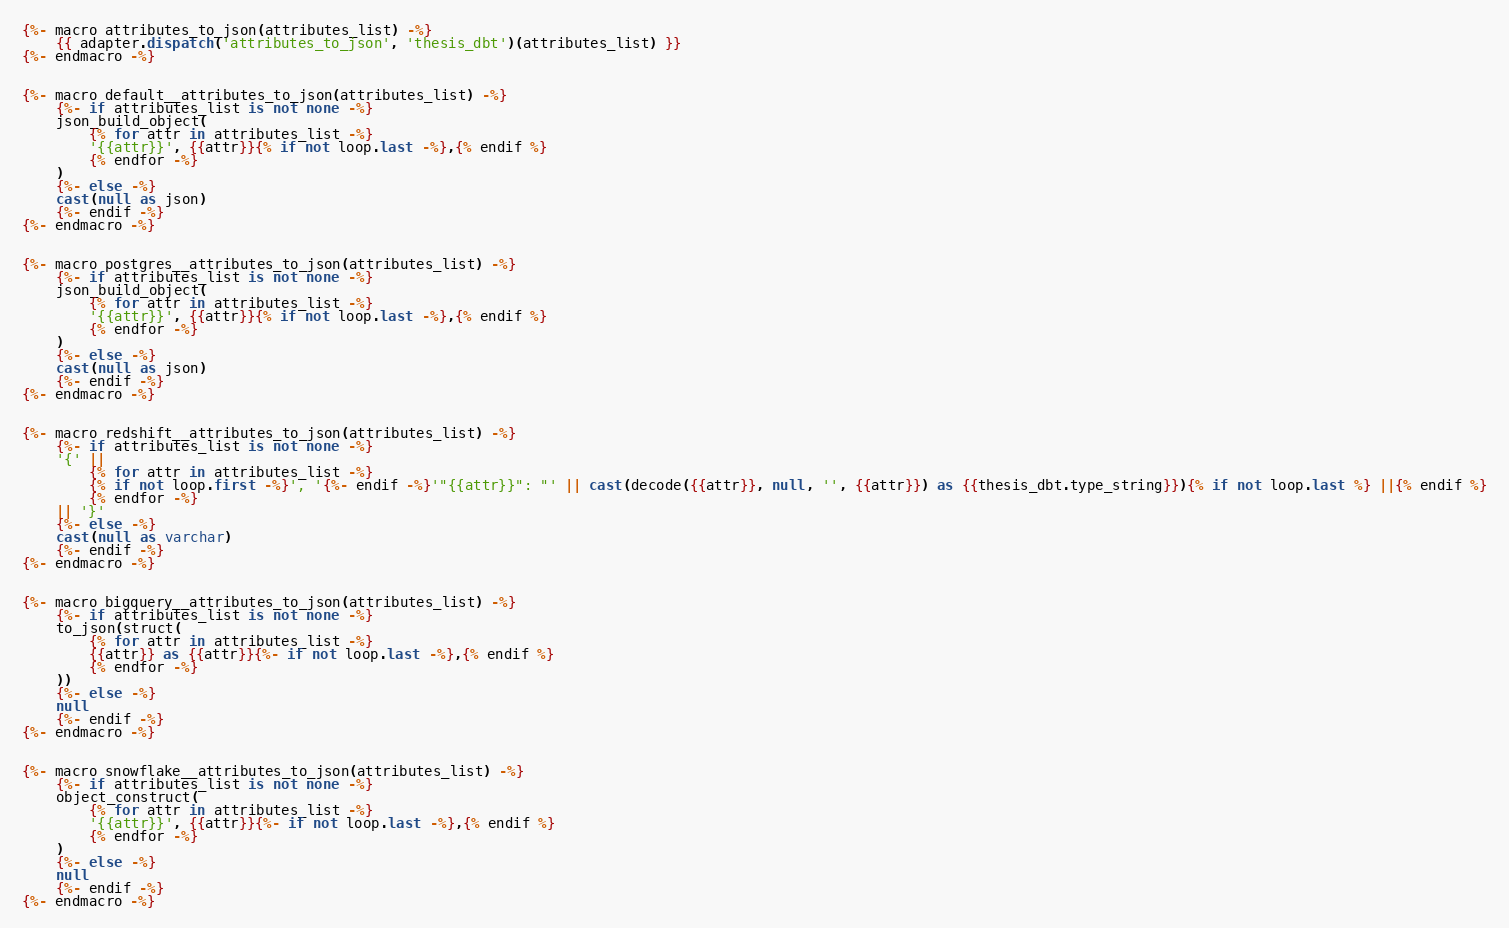Convert code to text. <code><loc_0><loc_0><loc_500><loc_500><_SQL_>{%- macro attributes_to_json(attributes_list) -%}
    {{ adapter.dispatch('attributes_to_json', 'thesis_dbt')(attributes_list) }}
{%- endmacro -%}


{%- macro default__attributes_to_json(attributes_list) -%}
    {%- if attributes_list is not none -%}
    json_build_object(
        {% for attr in attributes_list -%}
        '{{attr}}', {{attr}}{% if not loop.last -%},{% endif %}
        {% endfor -%}
    )
    {%- else -%}
    cast(null as json)
    {%- endif -%}
{%- endmacro -%}


{%- macro postgres__attributes_to_json(attributes_list) -%}
    {%- if attributes_list is not none -%}
    json_build_object(
        {% for attr in attributes_list -%}
        '{{attr}}', {{attr}}{% if not loop.last -%},{% endif %}
        {% endfor -%}
    )
    {%- else -%}
    cast(null as json)
    {%- endif -%}
{%- endmacro -%}


{%- macro redshift__attributes_to_json(attributes_list) -%}
    {%- if attributes_list is not none -%}
    '{' ||
        {% for attr in attributes_list -%}
        {% if not loop.first -%}', '{%- endif -%}'"{{attr}}": "' || cast(decode({{attr}}, null, '', {{attr}}) as {{thesis_dbt.type_string}}){% if not loop.last %} ||{% endif %}
        {% endfor -%}
    || '}'
    {%- else -%}
    cast(null as varchar)
    {%- endif -%}
{%- endmacro -%}


{%- macro bigquery__attributes_to_json(attributes_list) -%}
    {%- if attributes_list is not none -%}
    to_json(struct(
        {% for attr in attributes_list -%}
        {{attr}} as {{attr}}{%- if not loop.last -%},{% endif %}
        {% endfor -%}
    ))
    {%- else -%}
    null
    {%- endif -%}
{%- endmacro -%}


{%- macro snowflake__attributes_to_json(attributes_list) -%}
    {%- if attributes_list is not none -%}
    object_construct(
        {% for attr in attributes_list -%}
        '{{attr}}', {{attr}}{%- if not loop.last -%},{% endif %}
        {% endfor -%}
    )
    {%- else -%}
    null
    {%- endif -%}
{%- endmacro -%}
</code> 